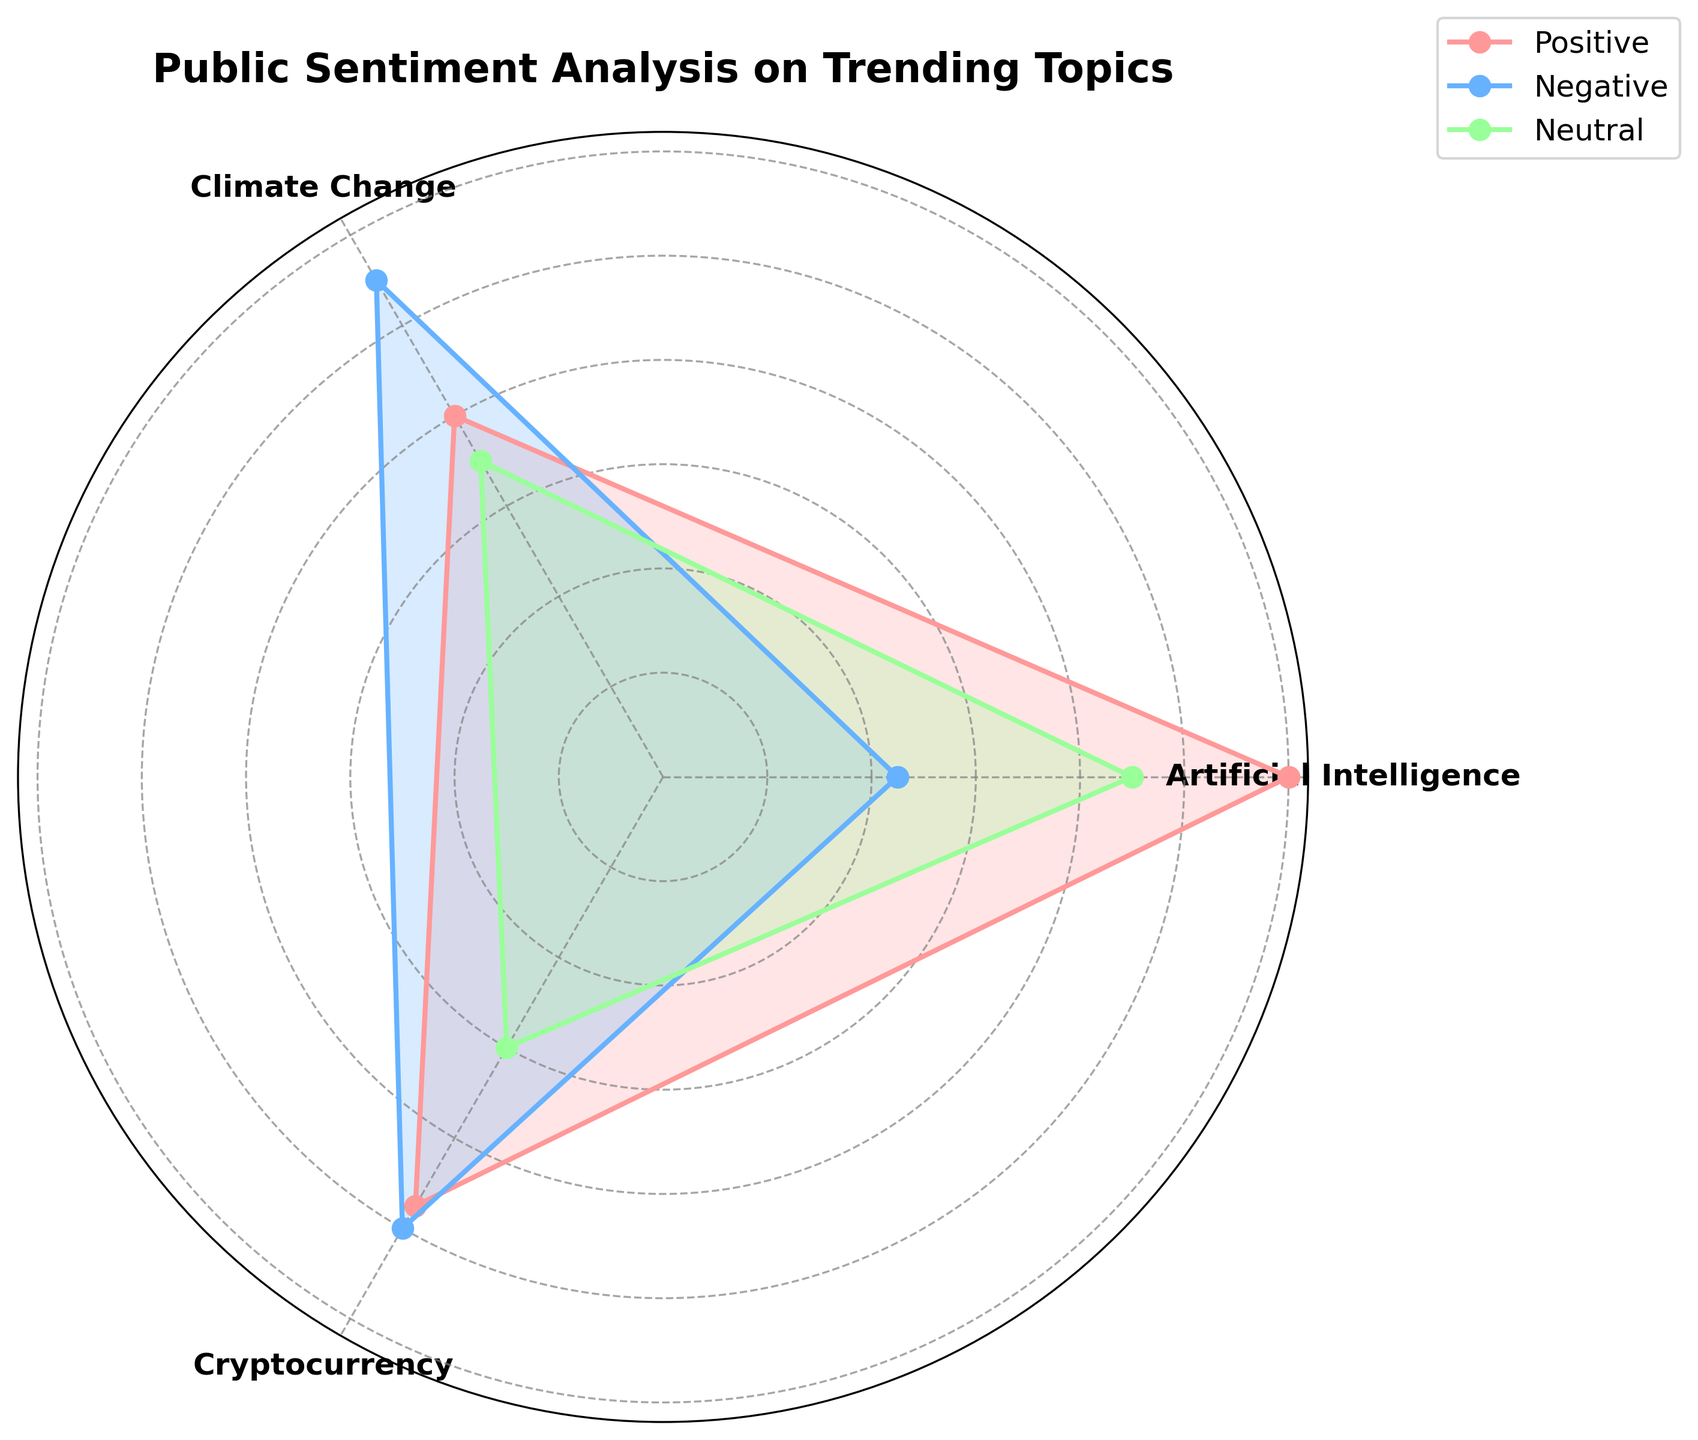What is the title of the chart? The title can be found at the top of the chart and it indicates the subject of the visualization. In this case, the title is "Public Sentiment Analysis on Trending Topics".
Answer: Public Sentiment Analysis on Trending Topics What are the sentiment types shown in the chart? To find the sentiment types, look at the legend on the right side of the chart. Each type is represented by a different color. The sentiment types are Positive, Negative, and Neutral.
Answer: Positive, Negative, Neutral Which topic has the highest positive sentiment count? To determine this, look at the radial values for each topic in the Positive sentiment section. Identify the highest value and the corresponding topic. Artificial Intelligence has the highest positive sentiment count at 120.
Answer: Artificial Intelligence What is the total count of sentiment for Cryptocurrency? Sum the counts of Positive, Negative, and Neutral sentiments for Cryptocurrency. These counts are 95 (Positive), 100 (Negative), and 60 (Neutral). So, the total count is 95 + 100 + 60 = 255.
Answer: 255 How many sentiment types have a count greater than 100 for Artificial Intelligence? Examine the individual count values for Artificial Intelligence in each sentiment type. Positive has 120, Negative has 45, and Neutral has 90. Only Positive (120) is greater than 100.
Answer: 1 Which sentiment type has the smallest range of values across all topics? Calculate the range for each sentiment type and compare them. The ranges are: Positive (120-80=40), Negative (110-45=65), Neutral (90-60=30). Neutral has the smallest range.
Answer: Neutral For Climate Change, which sentiment type has the highest count? Look at the data for Climate Change and compare the count values of each sentiment type. Positive has 80, Negative has 110, and Neutral has 70. The highest count is from Negative sentiment.
Answer: Negative Are there any sentiment types where all topics have counts below 100? Check the individual counts for all topics within each sentiment type. Neutral sentiment has counts of 90 for Artificial Intelligence, 70 for Climate Change, and 60 for Cryptocurrency, all below 100.
Answer: Yes (Neutral) What is the average count of Negative sentiment across all topics? Sum the Negative sentiment counts for all topics and divide by the number of topics. The counts are 45 (AI) + 110 (Climate Change) + 100 (Cryptocurrency) = 255. The average is 255 / 3 = 85.
Answer: 85 